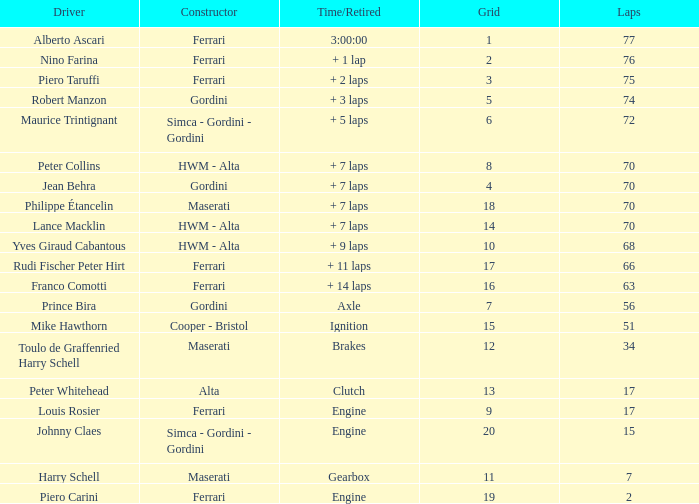How many grids for peter collins? 1.0. 